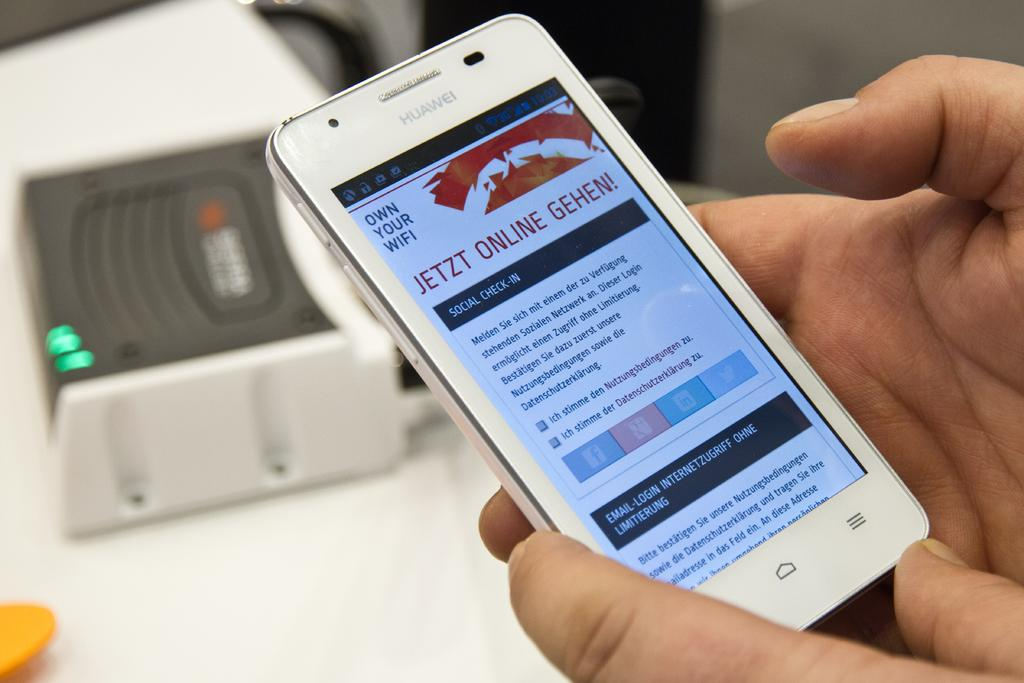Provide a one-sentence caption for the provided image. A person holding their phone that's on a page with the title Jetzt Online Gehen. 